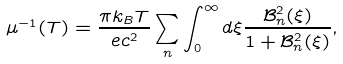Convert formula to latex. <formula><loc_0><loc_0><loc_500><loc_500>\mu ^ { - 1 } ( T ) = \frac { \pi k _ { B } T } { e c ^ { 2 } } \sum _ { n } \int _ { 0 } ^ { \infty } d \xi \frac { \mathcal { B } _ { n } ^ { 2 } ( \xi ) } { 1 + \mathcal { B } _ { n } ^ { 2 } ( \xi ) } ,</formula> 